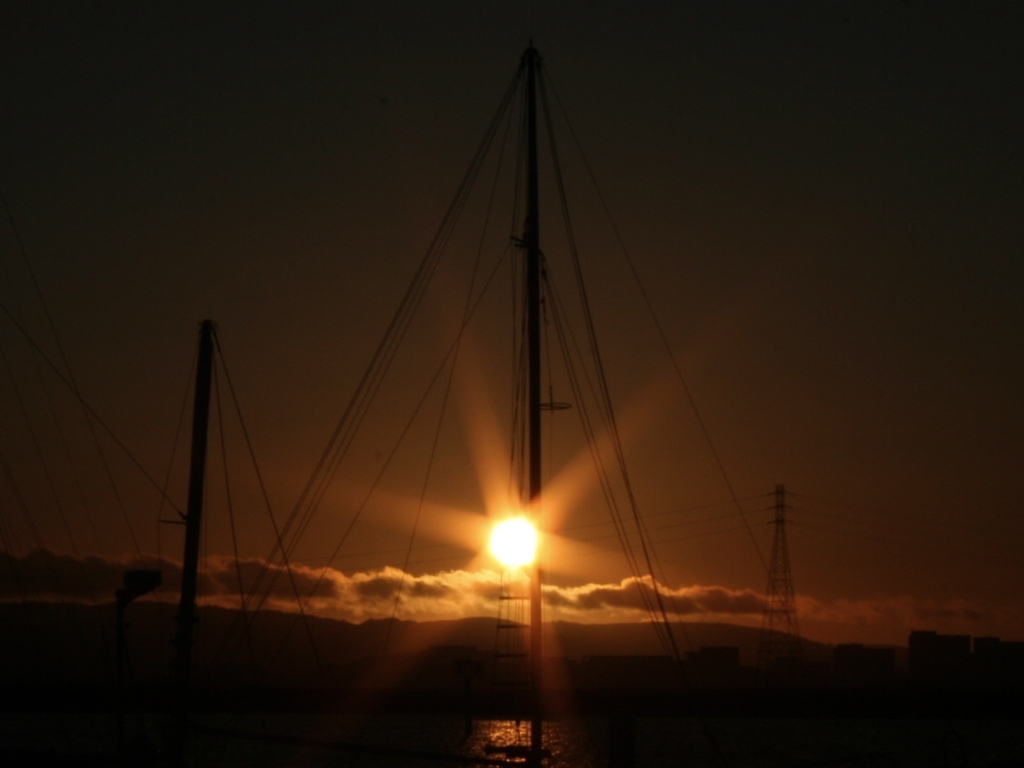What can you infer about the location from the image? The presence of masts indicates a dock or marina, likely near a bay or harbor given the expansive sky and the distant hills or mountains. The presence of power lines and structures in the silhouette also suggests a populated area nearby. 